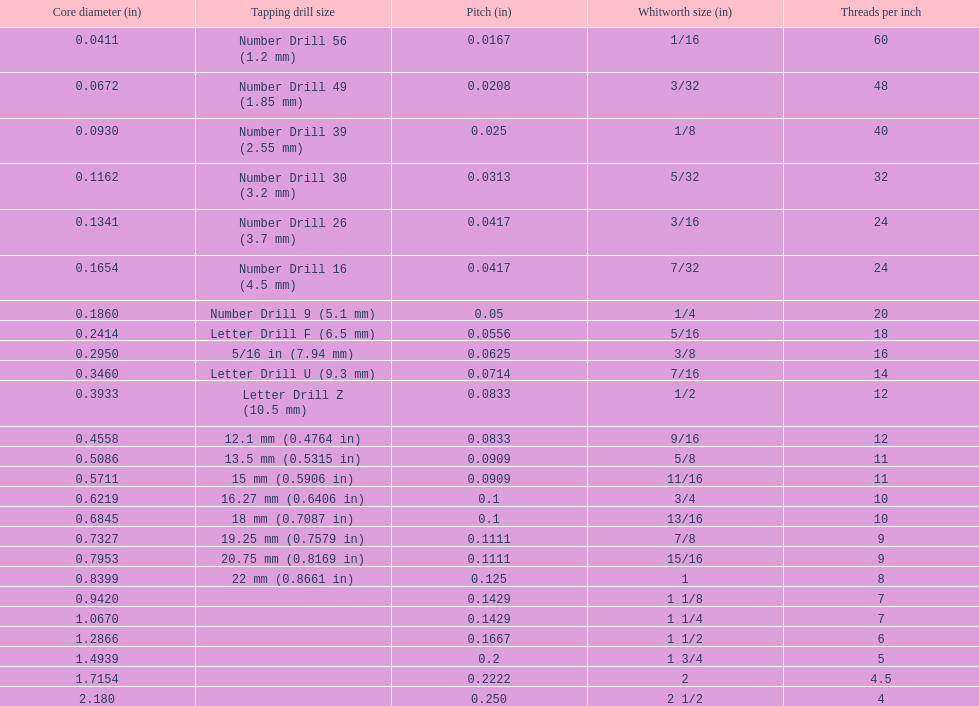Which whitworth size is the only one with 5 threads per inch? 1 3/4. 